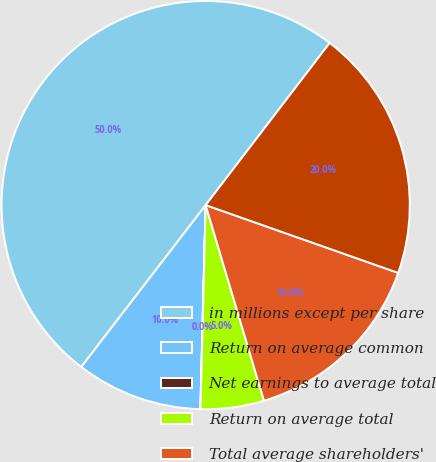Convert chart. <chart><loc_0><loc_0><loc_500><loc_500><pie_chart><fcel>in millions except per share<fcel>Return on average common<fcel>Net earnings to average total<fcel>Return on average total<fcel>Total average shareholders'<fcel>Dividend payout ratio<nl><fcel>49.97%<fcel>10.01%<fcel>0.02%<fcel>5.01%<fcel>15.0%<fcel>20.0%<nl></chart> 